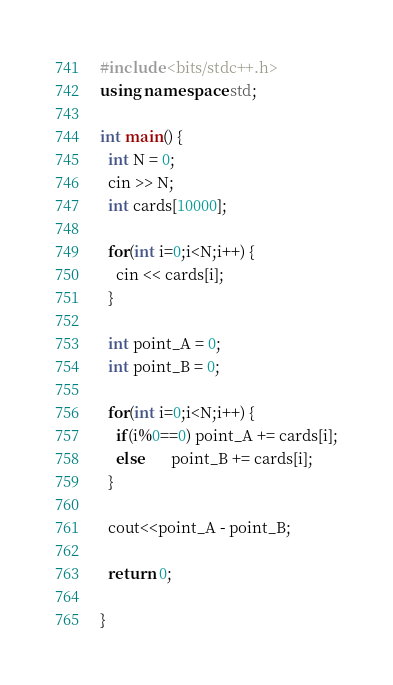<code> <loc_0><loc_0><loc_500><loc_500><_C++_>#include <bits/stdc++.h>
using namespace std;
 
int main() {
  int N = 0;
  cin >> N;
  int cards[10000];
  
  for(int i=0;i<N;i++) {
    cin << cards[i];
  }
 
  int point_A = 0;
  int point_B = 0;
  	
  for(int i=0;i<N;i++) {
    if(i%0==0) point_A += cards[i];
    else       point_B += cards[i];
  }
  
  cout<<point_A - point_B;
  
  return 0;
  
}</code> 